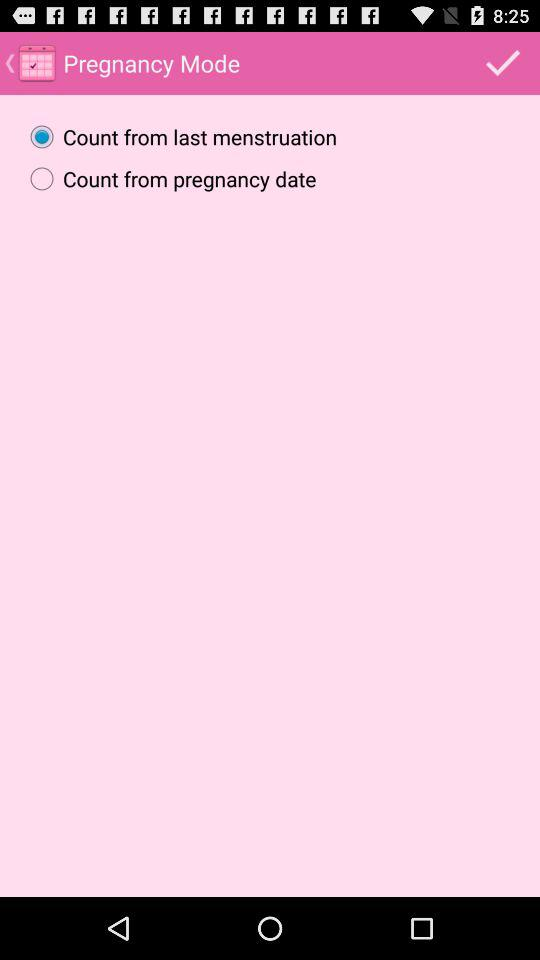Is "Count from pregnancy date" selected or not? "Count from pregnancy date" is not selected. 